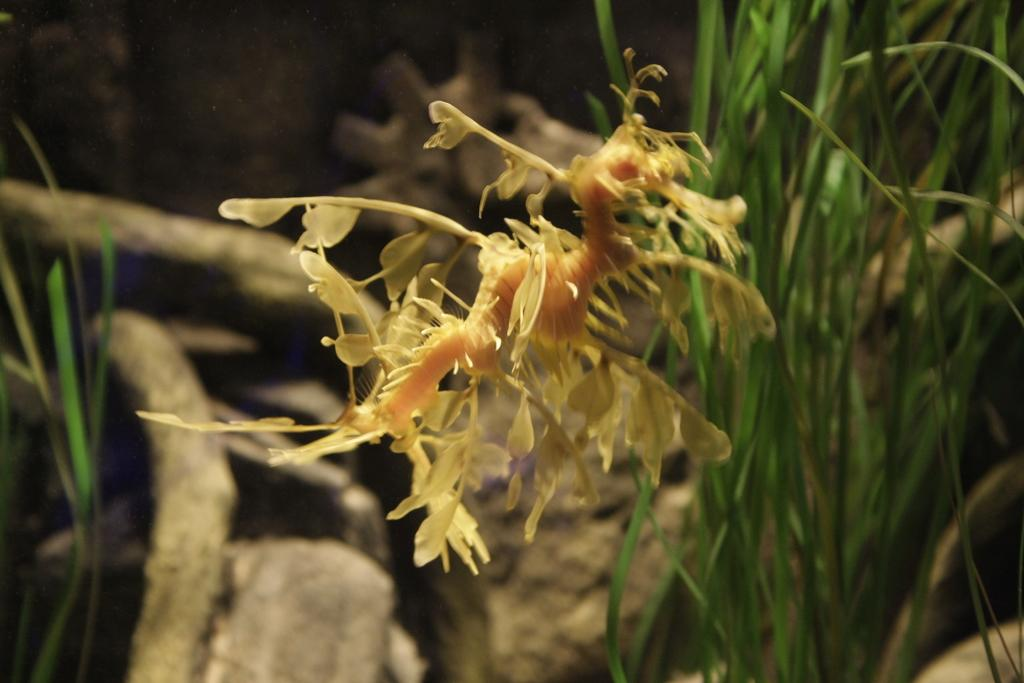What type of creature can be seen in the image? There is an insect in the image. What type of natural elements are present in the image? There are rocks and grass in the image. How would you describe the background of the image? The background of the image is blurred. What type of cherry is being washed in the basin in the image? There is no basin or cherry present in the image. 